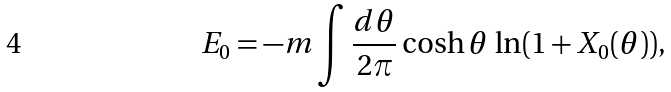<formula> <loc_0><loc_0><loc_500><loc_500>E _ { 0 } = - m \int { \frac { d \theta } { 2 \pi } } \cosh \theta \, \ln ( 1 + X _ { 0 } ( \theta ) ) ,</formula> 